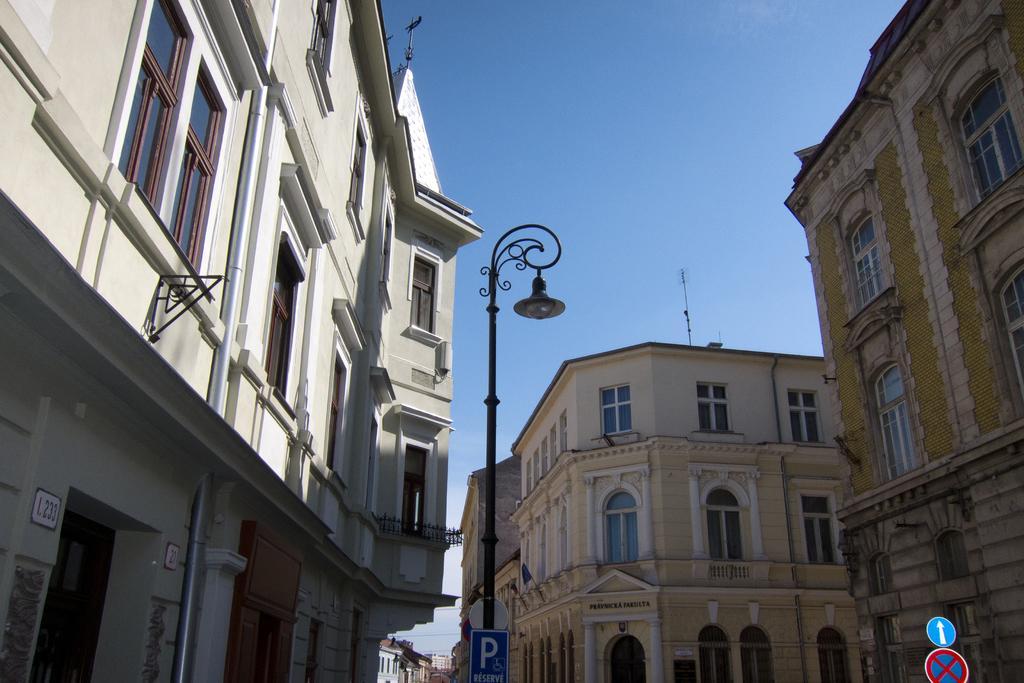Please provide a concise description of this image. In the picture we can see a some three buildings side by side with windows and near to it, we can see some pole with a lamp and some pole with a stop board, in the background we can see a sky. 